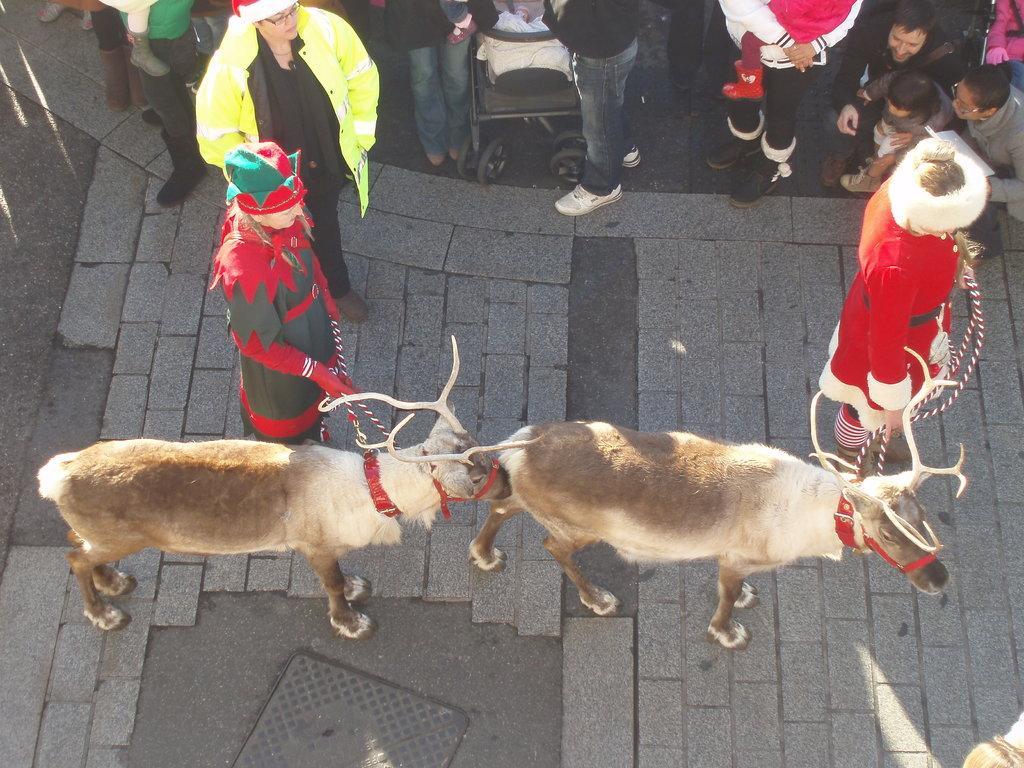Describe this image in one or two sentences. In this image we can see two persons holding the animals, in the background, we can see a few people are truncated and there is a stroller. 